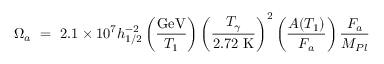Convert formula to latex. <formula><loc_0><loc_0><loc_500><loc_500>\Omega _ { a } \ = \ 2 . 1 \times 1 0 ^ { 7 } h _ { 1 / 2 } ^ { - 2 } \left ( { \frac { G e V } { T _ { 1 } } } \right ) \left ( \frac { T _ { \gamma } } { 2 . 7 2 \ K } \right ) ^ { 2 } \left ( { \frac { A ( T _ { 1 } ) } { F _ { a } } } \right ) { \frac { F _ { a } } { M _ { P l } } }</formula> 